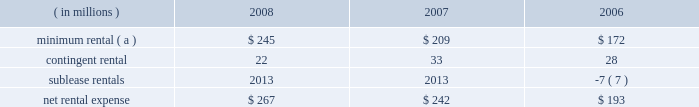Marathon oil corporation notes to consolidated financial statements operating lease rental expense was : ( in millions ) 2008 2007 2006 minimum rental ( a ) $ 245 $ 209 $ 172 .
( a ) excludes $ 5 million , $ 8 million and $ 9 million paid by united states steel in 2008 , 2007 and 2006 on assumed leases .
27 .
Contingencies and commitments we are the subject of , or party to , a number of pending or threatened legal actions , contingencies and commitments involving a variety of matters , including laws and regulations relating to the environment .
Certain of these matters are discussed below .
The ultimate resolution of these contingencies could , individually or in the aggregate , be material to our consolidated financial statements .
However , management believes that we will remain a viable and competitive enterprise even though it is possible that these contingencies could be resolved unfavorably .
Environmental matters 2013 we are subject to federal , state , local and foreign laws and regulations relating to the environment .
These laws generally provide for control of pollutants released into the environment and require responsible parties to undertake remediation of hazardous waste disposal sites .
Penalties may be imposed for noncompliance .
At december 31 , 2008 and 2007 , accrued liabilities for remediation totaled $ 111 million and $ 108 million .
It is not presently possible to estimate the ultimate amount of all remediation costs that might be incurred or the penalties that may be imposed .
Receivables for recoverable costs from certain states , under programs to assist companies in clean-up efforts related to underground storage tanks at retail marketing outlets , were $ 60 and $ 66 million at december 31 , 2008 and 2007 .
We are a defendant , along with other refining companies , in 20 cases arising in three states alleging damages for methyl tertiary-butyl ether ( 201cmtbe 201d ) contamination .
We have also received seven toxic substances control act notice letters involving potential claims in two states .
Such notice letters are often followed by litigation .
Like the cases that were settled in 2008 , the remaining mtbe cases are consolidated in a multidistrict litigation in the southern district of new york for pretrial proceedings .
Nineteen of the remaining cases allege damages to water supply wells , similar to the damages claimed in the settled cases .
In the other remaining case , the state of new jersey is seeking natural resources damages allegedly resulting from contamination of groundwater by mtbe .
This is the only mtbe contamination case in which we are a defendant and natural resources damages are sought .
We are vigorously defending these cases .
We , along with a number of other defendants , have engaged in settlement discussions related to the majority of the cases in which we are a defendant .
We do not expect our share of liability , if any , for the remaining cases to significantly impact our consolidated results of operations , financial position or cash flows .
A lawsuit filed in the united states district court for the southern district of west virginia alleges that our catlettsburg , kentucky , refinery distributed contaminated gasoline to wholesalers and retailers for a period prior to august , 2003 , causing permanent damage to storage tanks , dispensers and related equipment , resulting in lost profits , business disruption and personal and real property damages .
Following the incident , we conducted remediation operations at affected facilities , and we deny that any permanent damages resulted from the incident .
Class action certification was granted in august 2007 .
We have entered into a tentative settlement agreement in this case .
Notice of the proposed settlement has been sent to the class members .
Approval by the court after a fairness hearing is required before the settlement can be finalized .
The fairness hearing is scheduled in the first quarter of 2009 .
The proposed settlement will not significantly impact our consolidated results of operations , financial position or cash flows .
Guarantees 2013 we have provided certain guarantees , direct and indirect , of the indebtedness of other companies .
Under the terms of most of these guarantee arrangements , we would be required to perform should the guaranteed party fail to fulfill its obligations under the specified arrangements .
In addition to these financial guarantees , we also have various performance guarantees related to specific agreements. .
By how much did minimum rental increase from 2006 to 2008? 
Computations: ((245 - 172) / 172)
Answer: 0.42442. 